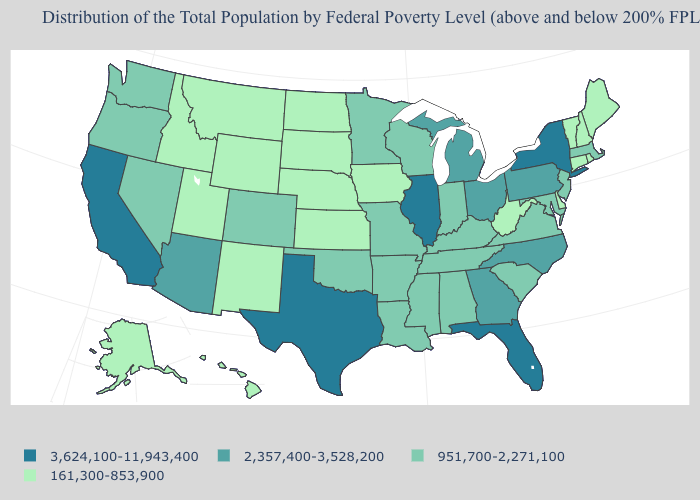How many symbols are there in the legend?
Concise answer only. 4. Name the states that have a value in the range 951,700-2,271,100?
Keep it brief. Alabama, Arkansas, Colorado, Indiana, Kentucky, Louisiana, Maryland, Massachusetts, Minnesota, Mississippi, Missouri, Nevada, New Jersey, Oklahoma, Oregon, South Carolina, Tennessee, Virginia, Washington, Wisconsin. Among the states that border New Mexico , does Texas have the highest value?
Quick response, please. Yes. What is the value of New Jersey?
Short answer required. 951,700-2,271,100. What is the value of Vermont?
Concise answer only. 161,300-853,900. Among the states that border Vermont , which have the lowest value?
Keep it brief. New Hampshire. Among the states that border Ohio , which have the highest value?
Be succinct. Michigan, Pennsylvania. Among the states that border Wisconsin , does Michigan have the lowest value?
Write a very short answer. No. What is the lowest value in the MidWest?
Keep it brief. 161,300-853,900. What is the value of Georgia?
Short answer required. 2,357,400-3,528,200. Name the states that have a value in the range 951,700-2,271,100?
Answer briefly. Alabama, Arkansas, Colorado, Indiana, Kentucky, Louisiana, Maryland, Massachusetts, Minnesota, Mississippi, Missouri, Nevada, New Jersey, Oklahoma, Oregon, South Carolina, Tennessee, Virginia, Washington, Wisconsin. Does Arkansas have the highest value in the South?
Write a very short answer. No. Does Tennessee have a lower value than North Carolina?
Write a very short answer. Yes. Does Arkansas have a higher value than Iowa?
Be succinct. Yes. 